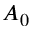<formula> <loc_0><loc_0><loc_500><loc_500>A _ { 0 }</formula> 